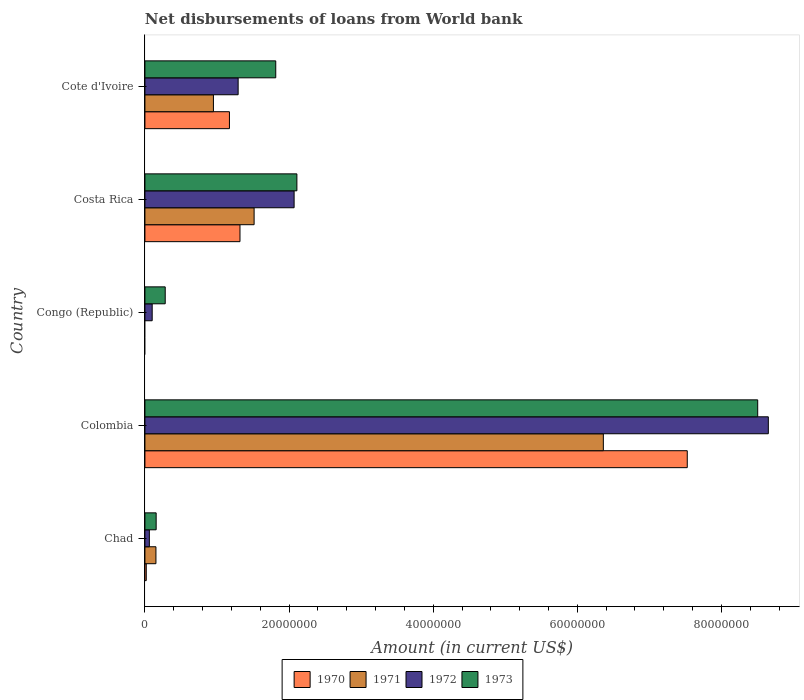How many different coloured bars are there?
Ensure brevity in your answer.  4. How many groups of bars are there?
Keep it short and to the point. 5. How many bars are there on the 5th tick from the top?
Ensure brevity in your answer.  4. What is the label of the 5th group of bars from the top?
Your response must be concise. Chad. In how many cases, is the number of bars for a given country not equal to the number of legend labels?
Give a very brief answer. 1. What is the amount of loan disbursed from World Bank in 1970 in Cote d'Ivoire?
Ensure brevity in your answer.  1.17e+07. Across all countries, what is the maximum amount of loan disbursed from World Bank in 1970?
Ensure brevity in your answer.  7.53e+07. What is the total amount of loan disbursed from World Bank in 1973 in the graph?
Your response must be concise. 1.29e+08. What is the difference between the amount of loan disbursed from World Bank in 1973 in Chad and that in Costa Rica?
Make the answer very short. -1.95e+07. What is the difference between the amount of loan disbursed from World Bank in 1972 in Chad and the amount of loan disbursed from World Bank in 1973 in Congo (Republic)?
Provide a short and direct response. -2.20e+06. What is the average amount of loan disbursed from World Bank in 1970 per country?
Your answer should be very brief. 2.01e+07. What is the difference between the amount of loan disbursed from World Bank in 1972 and amount of loan disbursed from World Bank in 1973 in Congo (Republic)?
Your answer should be very brief. -1.81e+06. What is the ratio of the amount of loan disbursed from World Bank in 1972 in Chad to that in Congo (Republic)?
Your answer should be very brief. 0.61. What is the difference between the highest and the second highest amount of loan disbursed from World Bank in 1972?
Offer a very short reply. 6.58e+07. What is the difference between the highest and the lowest amount of loan disbursed from World Bank in 1973?
Provide a succinct answer. 8.35e+07. In how many countries, is the amount of loan disbursed from World Bank in 1970 greater than the average amount of loan disbursed from World Bank in 1970 taken over all countries?
Offer a very short reply. 1. Is the sum of the amount of loan disbursed from World Bank in 1972 in Chad and Congo (Republic) greater than the maximum amount of loan disbursed from World Bank in 1970 across all countries?
Your answer should be compact. No. Does the graph contain grids?
Make the answer very short. No. How are the legend labels stacked?
Your answer should be compact. Horizontal. What is the title of the graph?
Give a very brief answer. Net disbursements of loans from World bank. Does "1969" appear as one of the legend labels in the graph?
Make the answer very short. No. What is the label or title of the X-axis?
Provide a succinct answer. Amount (in current US$). What is the Amount (in current US$) of 1970 in Chad?
Your answer should be very brief. 1.86e+05. What is the Amount (in current US$) of 1971 in Chad?
Make the answer very short. 1.53e+06. What is the Amount (in current US$) in 1972 in Chad?
Offer a very short reply. 6.17e+05. What is the Amount (in current US$) of 1973 in Chad?
Ensure brevity in your answer.  1.56e+06. What is the Amount (in current US$) of 1970 in Colombia?
Keep it short and to the point. 7.53e+07. What is the Amount (in current US$) of 1971 in Colombia?
Provide a short and direct response. 6.36e+07. What is the Amount (in current US$) of 1972 in Colombia?
Your answer should be compact. 8.65e+07. What is the Amount (in current US$) in 1973 in Colombia?
Ensure brevity in your answer.  8.50e+07. What is the Amount (in current US$) of 1971 in Congo (Republic)?
Ensure brevity in your answer.  0. What is the Amount (in current US$) in 1972 in Congo (Republic)?
Your answer should be very brief. 1.01e+06. What is the Amount (in current US$) of 1973 in Congo (Republic)?
Offer a terse response. 2.82e+06. What is the Amount (in current US$) in 1970 in Costa Rica?
Your answer should be compact. 1.32e+07. What is the Amount (in current US$) of 1971 in Costa Rica?
Your answer should be very brief. 1.52e+07. What is the Amount (in current US$) in 1972 in Costa Rica?
Your answer should be very brief. 2.07e+07. What is the Amount (in current US$) in 1973 in Costa Rica?
Provide a succinct answer. 2.11e+07. What is the Amount (in current US$) in 1970 in Cote d'Ivoire?
Your answer should be compact. 1.17e+07. What is the Amount (in current US$) of 1971 in Cote d'Ivoire?
Ensure brevity in your answer.  9.51e+06. What is the Amount (in current US$) of 1972 in Cote d'Ivoire?
Your response must be concise. 1.29e+07. What is the Amount (in current US$) in 1973 in Cote d'Ivoire?
Provide a short and direct response. 1.82e+07. Across all countries, what is the maximum Amount (in current US$) in 1970?
Provide a short and direct response. 7.53e+07. Across all countries, what is the maximum Amount (in current US$) in 1971?
Ensure brevity in your answer.  6.36e+07. Across all countries, what is the maximum Amount (in current US$) of 1972?
Your answer should be very brief. 8.65e+07. Across all countries, what is the maximum Amount (in current US$) in 1973?
Make the answer very short. 8.50e+07. Across all countries, what is the minimum Amount (in current US$) of 1970?
Provide a succinct answer. 0. Across all countries, what is the minimum Amount (in current US$) of 1972?
Keep it short and to the point. 6.17e+05. Across all countries, what is the minimum Amount (in current US$) in 1973?
Ensure brevity in your answer.  1.56e+06. What is the total Amount (in current US$) of 1970 in the graph?
Provide a short and direct response. 1.00e+08. What is the total Amount (in current US$) of 1971 in the graph?
Offer a terse response. 8.98e+07. What is the total Amount (in current US$) of 1972 in the graph?
Your answer should be very brief. 1.22e+08. What is the total Amount (in current US$) in 1973 in the graph?
Ensure brevity in your answer.  1.29e+08. What is the difference between the Amount (in current US$) in 1970 in Chad and that in Colombia?
Provide a short and direct response. -7.51e+07. What is the difference between the Amount (in current US$) of 1971 in Chad and that in Colombia?
Ensure brevity in your answer.  -6.21e+07. What is the difference between the Amount (in current US$) in 1972 in Chad and that in Colombia?
Keep it short and to the point. -8.59e+07. What is the difference between the Amount (in current US$) in 1973 in Chad and that in Colombia?
Give a very brief answer. -8.35e+07. What is the difference between the Amount (in current US$) of 1972 in Chad and that in Congo (Republic)?
Offer a terse response. -3.92e+05. What is the difference between the Amount (in current US$) in 1973 in Chad and that in Congo (Republic)?
Provide a short and direct response. -1.26e+06. What is the difference between the Amount (in current US$) in 1970 in Chad and that in Costa Rica?
Keep it short and to the point. -1.30e+07. What is the difference between the Amount (in current US$) in 1971 in Chad and that in Costa Rica?
Your response must be concise. -1.36e+07. What is the difference between the Amount (in current US$) of 1972 in Chad and that in Costa Rica?
Ensure brevity in your answer.  -2.01e+07. What is the difference between the Amount (in current US$) of 1973 in Chad and that in Costa Rica?
Your answer should be very brief. -1.95e+07. What is the difference between the Amount (in current US$) in 1970 in Chad and that in Cote d'Ivoire?
Keep it short and to the point. -1.15e+07. What is the difference between the Amount (in current US$) of 1971 in Chad and that in Cote d'Ivoire?
Keep it short and to the point. -7.98e+06. What is the difference between the Amount (in current US$) in 1972 in Chad and that in Cote d'Ivoire?
Your response must be concise. -1.23e+07. What is the difference between the Amount (in current US$) in 1973 in Chad and that in Cote d'Ivoire?
Your answer should be very brief. -1.66e+07. What is the difference between the Amount (in current US$) of 1972 in Colombia and that in Congo (Republic)?
Your answer should be compact. 8.55e+07. What is the difference between the Amount (in current US$) of 1973 in Colombia and that in Congo (Republic)?
Make the answer very short. 8.22e+07. What is the difference between the Amount (in current US$) in 1970 in Colombia and that in Costa Rica?
Ensure brevity in your answer.  6.21e+07. What is the difference between the Amount (in current US$) of 1971 in Colombia and that in Costa Rica?
Keep it short and to the point. 4.85e+07. What is the difference between the Amount (in current US$) in 1972 in Colombia and that in Costa Rica?
Your answer should be very brief. 6.58e+07. What is the difference between the Amount (in current US$) in 1973 in Colombia and that in Costa Rica?
Make the answer very short. 6.39e+07. What is the difference between the Amount (in current US$) of 1970 in Colombia and that in Cote d'Ivoire?
Keep it short and to the point. 6.35e+07. What is the difference between the Amount (in current US$) in 1971 in Colombia and that in Cote d'Ivoire?
Offer a very short reply. 5.41e+07. What is the difference between the Amount (in current US$) of 1972 in Colombia and that in Cote d'Ivoire?
Provide a short and direct response. 7.36e+07. What is the difference between the Amount (in current US$) of 1973 in Colombia and that in Cote d'Ivoire?
Make the answer very short. 6.69e+07. What is the difference between the Amount (in current US$) of 1972 in Congo (Republic) and that in Costa Rica?
Keep it short and to the point. -1.97e+07. What is the difference between the Amount (in current US$) in 1973 in Congo (Republic) and that in Costa Rica?
Offer a very short reply. -1.83e+07. What is the difference between the Amount (in current US$) in 1972 in Congo (Republic) and that in Cote d'Ivoire?
Make the answer very short. -1.19e+07. What is the difference between the Amount (in current US$) of 1973 in Congo (Republic) and that in Cote d'Ivoire?
Keep it short and to the point. -1.53e+07. What is the difference between the Amount (in current US$) in 1970 in Costa Rica and that in Cote d'Ivoire?
Offer a terse response. 1.46e+06. What is the difference between the Amount (in current US$) of 1971 in Costa Rica and that in Cote d'Ivoire?
Provide a succinct answer. 5.65e+06. What is the difference between the Amount (in current US$) in 1972 in Costa Rica and that in Cote d'Ivoire?
Provide a succinct answer. 7.77e+06. What is the difference between the Amount (in current US$) in 1973 in Costa Rica and that in Cote d'Ivoire?
Offer a terse response. 2.93e+06. What is the difference between the Amount (in current US$) in 1970 in Chad and the Amount (in current US$) in 1971 in Colombia?
Your answer should be compact. -6.34e+07. What is the difference between the Amount (in current US$) of 1970 in Chad and the Amount (in current US$) of 1972 in Colombia?
Your response must be concise. -8.63e+07. What is the difference between the Amount (in current US$) in 1970 in Chad and the Amount (in current US$) in 1973 in Colombia?
Ensure brevity in your answer.  -8.48e+07. What is the difference between the Amount (in current US$) in 1971 in Chad and the Amount (in current US$) in 1972 in Colombia?
Offer a very short reply. -8.50e+07. What is the difference between the Amount (in current US$) of 1971 in Chad and the Amount (in current US$) of 1973 in Colombia?
Offer a terse response. -8.35e+07. What is the difference between the Amount (in current US$) in 1972 in Chad and the Amount (in current US$) in 1973 in Colombia?
Offer a very short reply. -8.44e+07. What is the difference between the Amount (in current US$) in 1970 in Chad and the Amount (in current US$) in 1972 in Congo (Republic)?
Give a very brief answer. -8.23e+05. What is the difference between the Amount (in current US$) of 1970 in Chad and the Amount (in current US$) of 1973 in Congo (Republic)?
Your answer should be compact. -2.63e+06. What is the difference between the Amount (in current US$) of 1971 in Chad and the Amount (in current US$) of 1972 in Congo (Republic)?
Your answer should be compact. 5.21e+05. What is the difference between the Amount (in current US$) in 1971 in Chad and the Amount (in current US$) in 1973 in Congo (Republic)?
Your answer should be compact. -1.29e+06. What is the difference between the Amount (in current US$) of 1972 in Chad and the Amount (in current US$) of 1973 in Congo (Republic)?
Your answer should be very brief. -2.20e+06. What is the difference between the Amount (in current US$) of 1970 in Chad and the Amount (in current US$) of 1971 in Costa Rica?
Offer a terse response. -1.50e+07. What is the difference between the Amount (in current US$) in 1970 in Chad and the Amount (in current US$) in 1972 in Costa Rica?
Your response must be concise. -2.05e+07. What is the difference between the Amount (in current US$) in 1970 in Chad and the Amount (in current US$) in 1973 in Costa Rica?
Your response must be concise. -2.09e+07. What is the difference between the Amount (in current US$) of 1971 in Chad and the Amount (in current US$) of 1972 in Costa Rica?
Provide a short and direct response. -1.92e+07. What is the difference between the Amount (in current US$) of 1971 in Chad and the Amount (in current US$) of 1973 in Costa Rica?
Provide a short and direct response. -1.96e+07. What is the difference between the Amount (in current US$) of 1972 in Chad and the Amount (in current US$) of 1973 in Costa Rica?
Provide a succinct answer. -2.05e+07. What is the difference between the Amount (in current US$) in 1970 in Chad and the Amount (in current US$) in 1971 in Cote d'Ivoire?
Keep it short and to the point. -9.32e+06. What is the difference between the Amount (in current US$) of 1970 in Chad and the Amount (in current US$) of 1972 in Cote d'Ivoire?
Provide a short and direct response. -1.28e+07. What is the difference between the Amount (in current US$) in 1970 in Chad and the Amount (in current US$) in 1973 in Cote d'Ivoire?
Provide a short and direct response. -1.80e+07. What is the difference between the Amount (in current US$) of 1971 in Chad and the Amount (in current US$) of 1972 in Cote d'Ivoire?
Ensure brevity in your answer.  -1.14e+07. What is the difference between the Amount (in current US$) of 1971 in Chad and the Amount (in current US$) of 1973 in Cote d'Ivoire?
Ensure brevity in your answer.  -1.66e+07. What is the difference between the Amount (in current US$) in 1972 in Chad and the Amount (in current US$) in 1973 in Cote d'Ivoire?
Provide a succinct answer. -1.75e+07. What is the difference between the Amount (in current US$) in 1970 in Colombia and the Amount (in current US$) in 1972 in Congo (Republic)?
Provide a succinct answer. 7.42e+07. What is the difference between the Amount (in current US$) in 1970 in Colombia and the Amount (in current US$) in 1973 in Congo (Republic)?
Your answer should be compact. 7.24e+07. What is the difference between the Amount (in current US$) in 1971 in Colombia and the Amount (in current US$) in 1972 in Congo (Republic)?
Your response must be concise. 6.26e+07. What is the difference between the Amount (in current US$) in 1971 in Colombia and the Amount (in current US$) in 1973 in Congo (Republic)?
Your answer should be very brief. 6.08e+07. What is the difference between the Amount (in current US$) in 1972 in Colombia and the Amount (in current US$) in 1973 in Congo (Republic)?
Your answer should be compact. 8.37e+07. What is the difference between the Amount (in current US$) of 1970 in Colombia and the Amount (in current US$) of 1971 in Costa Rica?
Keep it short and to the point. 6.01e+07. What is the difference between the Amount (in current US$) of 1970 in Colombia and the Amount (in current US$) of 1972 in Costa Rica?
Offer a terse response. 5.46e+07. What is the difference between the Amount (in current US$) of 1970 in Colombia and the Amount (in current US$) of 1973 in Costa Rica?
Provide a succinct answer. 5.42e+07. What is the difference between the Amount (in current US$) of 1971 in Colombia and the Amount (in current US$) of 1972 in Costa Rica?
Ensure brevity in your answer.  4.29e+07. What is the difference between the Amount (in current US$) of 1971 in Colombia and the Amount (in current US$) of 1973 in Costa Rica?
Provide a short and direct response. 4.25e+07. What is the difference between the Amount (in current US$) of 1972 in Colombia and the Amount (in current US$) of 1973 in Costa Rica?
Ensure brevity in your answer.  6.54e+07. What is the difference between the Amount (in current US$) in 1970 in Colombia and the Amount (in current US$) in 1971 in Cote d'Ivoire?
Keep it short and to the point. 6.58e+07. What is the difference between the Amount (in current US$) in 1970 in Colombia and the Amount (in current US$) in 1972 in Cote d'Ivoire?
Offer a terse response. 6.23e+07. What is the difference between the Amount (in current US$) of 1970 in Colombia and the Amount (in current US$) of 1973 in Cote d'Ivoire?
Provide a short and direct response. 5.71e+07. What is the difference between the Amount (in current US$) in 1971 in Colombia and the Amount (in current US$) in 1972 in Cote d'Ivoire?
Offer a terse response. 5.07e+07. What is the difference between the Amount (in current US$) of 1971 in Colombia and the Amount (in current US$) of 1973 in Cote d'Ivoire?
Your answer should be very brief. 4.55e+07. What is the difference between the Amount (in current US$) of 1972 in Colombia and the Amount (in current US$) of 1973 in Cote d'Ivoire?
Offer a terse response. 6.84e+07. What is the difference between the Amount (in current US$) of 1972 in Congo (Republic) and the Amount (in current US$) of 1973 in Costa Rica?
Ensure brevity in your answer.  -2.01e+07. What is the difference between the Amount (in current US$) in 1972 in Congo (Republic) and the Amount (in current US$) in 1973 in Cote d'Ivoire?
Keep it short and to the point. -1.71e+07. What is the difference between the Amount (in current US$) of 1970 in Costa Rica and the Amount (in current US$) of 1971 in Cote d'Ivoire?
Your response must be concise. 3.69e+06. What is the difference between the Amount (in current US$) in 1970 in Costa Rica and the Amount (in current US$) in 1972 in Cote d'Ivoire?
Provide a succinct answer. 2.56e+05. What is the difference between the Amount (in current US$) of 1970 in Costa Rica and the Amount (in current US$) of 1973 in Cote d'Ivoire?
Your answer should be compact. -4.96e+06. What is the difference between the Amount (in current US$) of 1971 in Costa Rica and the Amount (in current US$) of 1972 in Cote d'Ivoire?
Make the answer very short. 2.22e+06. What is the difference between the Amount (in current US$) of 1971 in Costa Rica and the Amount (in current US$) of 1973 in Cote d'Ivoire?
Give a very brief answer. -3.00e+06. What is the difference between the Amount (in current US$) in 1972 in Costa Rica and the Amount (in current US$) in 1973 in Cote d'Ivoire?
Make the answer very short. 2.55e+06. What is the average Amount (in current US$) in 1970 per country?
Offer a very short reply. 2.01e+07. What is the average Amount (in current US$) of 1971 per country?
Your answer should be very brief. 1.80e+07. What is the average Amount (in current US$) in 1972 per country?
Provide a succinct answer. 2.44e+07. What is the average Amount (in current US$) in 1973 per country?
Offer a terse response. 2.57e+07. What is the difference between the Amount (in current US$) of 1970 and Amount (in current US$) of 1971 in Chad?
Give a very brief answer. -1.34e+06. What is the difference between the Amount (in current US$) of 1970 and Amount (in current US$) of 1972 in Chad?
Make the answer very short. -4.31e+05. What is the difference between the Amount (in current US$) of 1970 and Amount (in current US$) of 1973 in Chad?
Your response must be concise. -1.37e+06. What is the difference between the Amount (in current US$) of 1971 and Amount (in current US$) of 1972 in Chad?
Your response must be concise. 9.13e+05. What is the difference between the Amount (in current US$) in 1971 and Amount (in current US$) in 1973 in Chad?
Offer a very short reply. -3.00e+04. What is the difference between the Amount (in current US$) in 1972 and Amount (in current US$) in 1973 in Chad?
Ensure brevity in your answer.  -9.43e+05. What is the difference between the Amount (in current US$) in 1970 and Amount (in current US$) in 1971 in Colombia?
Give a very brief answer. 1.16e+07. What is the difference between the Amount (in current US$) in 1970 and Amount (in current US$) in 1972 in Colombia?
Your response must be concise. -1.12e+07. What is the difference between the Amount (in current US$) of 1970 and Amount (in current US$) of 1973 in Colombia?
Keep it short and to the point. -9.77e+06. What is the difference between the Amount (in current US$) of 1971 and Amount (in current US$) of 1972 in Colombia?
Give a very brief answer. -2.29e+07. What is the difference between the Amount (in current US$) of 1971 and Amount (in current US$) of 1973 in Colombia?
Offer a very short reply. -2.14e+07. What is the difference between the Amount (in current US$) of 1972 and Amount (in current US$) of 1973 in Colombia?
Your response must be concise. 1.47e+06. What is the difference between the Amount (in current US$) of 1972 and Amount (in current US$) of 1973 in Congo (Republic)?
Offer a terse response. -1.81e+06. What is the difference between the Amount (in current US$) of 1970 and Amount (in current US$) of 1971 in Costa Rica?
Keep it short and to the point. -1.96e+06. What is the difference between the Amount (in current US$) in 1970 and Amount (in current US$) in 1972 in Costa Rica?
Provide a short and direct response. -7.51e+06. What is the difference between the Amount (in current US$) of 1970 and Amount (in current US$) of 1973 in Costa Rica?
Keep it short and to the point. -7.90e+06. What is the difference between the Amount (in current US$) of 1971 and Amount (in current US$) of 1972 in Costa Rica?
Provide a short and direct response. -5.55e+06. What is the difference between the Amount (in current US$) of 1971 and Amount (in current US$) of 1973 in Costa Rica?
Give a very brief answer. -5.94e+06. What is the difference between the Amount (in current US$) in 1972 and Amount (in current US$) in 1973 in Costa Rica?
Keep it short and to the point. -3.86e+05. What is the difference between the Amount (in current US$) of 1970 and Amount (in current US$) of 1971 in Cote d'Ivoire?
Your response must be concise. 2.22e+06. What is the difference between the Amount (in current US$) in 1970 and Amount (in current US$) in 1972 in Cote d'Ivoire?
Give a very brief answer. -1.21e+06. What is the difference between the Amount (in current US$) of 1970 and Amount (in current US$) of 1973 in Cote d'Ivoire?
Your answer should be very brief. -6.43e+06. What is the difference between the Amount (in current US$) of 1971 and Amount (in current US$) of 1972 in Cote d'Ivoire?
Give a very brief answer. -3.43e+06. What is the difference between the Amount (in current US$) of 1971 and Amount (in current US$) of 1973 in Cote d'Ivoire?
Ensure brevity in your answer.  -8.65e+06. What is the difference between the Amount (in current US$) in 1972 and Amount (in current US$) in 1973 in Cote d'Ivoire?
Offer a terse response. -5.22e+06. What is the ratio of the Amount (in current US$) in 1970 in Chad to that in Colombia?
Your response must be concise. 0. What is the ratio of the Amount (in current US$) in 1971 in Chad to that in Colombia?
Your response must be concise. 0.02. What is the ratio of the Amount (in current US$) of 1972 in Chad to that in Colombia?
Your answer should be very brief. 0.01. What is the ratio of the Amount (in current US$) in 1973 in Chad to that in Colombia?
Ensure brevity in your answer.  0.02. What is the ratio of the Amount (in current US$) in 1972 in Chad to that in Congo (Republic)?
Your answer should be compact. 0.61. What is the ratio of the Amount (in current US$) in 1973 in Chad to that in Congo (Republic)?
Give a very brief answer. 0.55. What is the ratio of the Amount (in current US$) in 1970 in Chad to that in Costa Rica?
Ensure brevity in your answer.  0.01. What is the ratio of the Amount (in current US$) of 1971 in Chad to that in Costa Rica?
Your response must be concise. 0.1. What is the ratio of the Amount (in current US$) in 1972 in Chad to that in Costa Rica?
Provide a succinct answer. 0.03. What is the ratio of the Amount (in current US$) of 1973 in Chad to that in Costa Rica?
Ensure brevity in your answer.  0.07. What is the ratio of the Amount (in current US$) in 1970 in Chad to that in Cote d'Ivoire?
Make the answer very short. 0.02. What is the ratio of the Amount (in current US$) of 1971 in Chad to that in Cote d'Ivoire?
Your answer should be compact. 0.16. What is the ratio of the Amount (in current US$) of 1972 in Chad to that in Cote d'Ivoire?
Make the answer very short. 0.05. What is the ratio of the Amount (in current US$) of 1973 in Chad to that in Cote d'Ivoire?
Keep it short and to the point. 0.09. What is the ratio of the Amount (in current US$) of 1972 in Colombia to that in Congo (Republic)?
Offer a terse response. 85.74. What is the ratio of the Amount (in current US$) of 1973 in Colombia to that in Congo (Republic)?
Offer a terse response. 30.2. What is the ratio of the Amount (in current US$) in 1970 in Colombia to that in Costa Rica?
Your response must be concise. 5.7. What is the ratio of the Amount (in current US$) of 1971 in Colombia to that in Costa Rica?
Your answer should be compact. 4.2. What is the ratio of the Amount (in current US$) in 1972 in Colombia to that in Costa Rica?
Make the answer very short. 4.18. What is the ratio of the Amount (in current US$) of 1973 in Colombia to that in Costa Rica?
Your answer should be very brief. 4.03. What is the ratio of the Amount (in current US$) in 1970 in Colombia to that in Cote d'Ivoire?
Make the answer very short. 6.42. What is the ratio of the Amount (in current US$) in 1971 in Colombia to that in Cote d'Ivoire?
Provide a succinct answer. 6.69. What is the ratio of the Amount (in current US$) in 1972 in Colombia to that in Cote d'Ivoire?
Provide a short and direct response. 6.69. What is the ratio of the Amount (in current US$) in 1973 in Colombia to that in Cote d'Ivoire?
Your answer should be very brief. 4.68. What is the ratio of the Amount (in current US$) of 1972 in Congo (Republic) to that in Costa Rica?
Your answer should be very brief. 0.05. What is the ratio of the Amount (in current US$) in 1973 in Congo (Republic) to that in Costa Rica?
Your answer should be compact. 0.13. What is the ratio of the Amount (in current US$) of 1972 in Congo (Republic) to that in Cote d'Ivoire?
Your answer should be compact. 0.08. What is the ratio of the Amount (in current US$) of 1973 in Congo (Republic) to that in Cote d'Ivoire?
Make the answer very short. 0.16. What is the ratio of the Amount (in current US$) in 1970 in Costa Rica to that in Cote d'Ivoire?
Your answer should be very brief. 1.12. What is the ratio of the Amount (in current US$) of 1971 in Costa Rica to that in Cote d'Ivoire?
Keep it short and to the point. 1.59. What is the ratio of the Amount (in current US$) of 1972 in Costa Rica to that in Cote d'Ivoire?
Make the answer very short. 1.6. What is the ratio of the Amount (in current US$) of 1973 in Costa Rica to that in Cote d'Ivoire?
Provide a short and direct response. 1.16. What is the difference between the highest and the second highest Amount (in current US$) of 1970?
Provide a succinct answer. 6.21e+07. What is the difference between the highest and the second highest Amount (in current US$) in 1971?
Make the answer very short. 4.85e+07. What is the difference between the highest and the second highest Amount (in current US$) in 1972?
Provide a short and direct response. 6.58e+07. What is the difference between the highest and the second highest Amount (in current US$) in 1973?
Your answer should be compact. 6.39e+07. What is the difference between the highest and the lowest Amount (in current US$) of 1970?
Your answer should be compact. 7.53e+07. What is the difference between the highest and the lowest Amount (in current US$) in 1971?
Offer a terse response. 6.36e+07. What is the difference between the highest and the lowest Amount (in current US$) in 1972?
Your answer should be compact. 8.59e+07. What is the difference between the highest and the lowest Amount (in current US$) in 1973?
Offer a very short reply. 8.35e+07. 